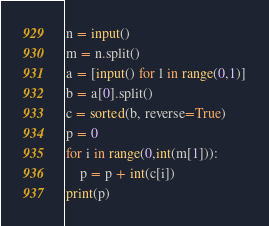<code> <loc_0><loc_0><loc_500><loc_500><_Python_>n = input()
m = n.split()
a = [input() for l in range(0,1)]
b = a[0].split()
c = sorted(b, reverse=True)
p = 0
for i in range(0,int(m[1])):
    p = p + int(c[i])
print(p)</code> 